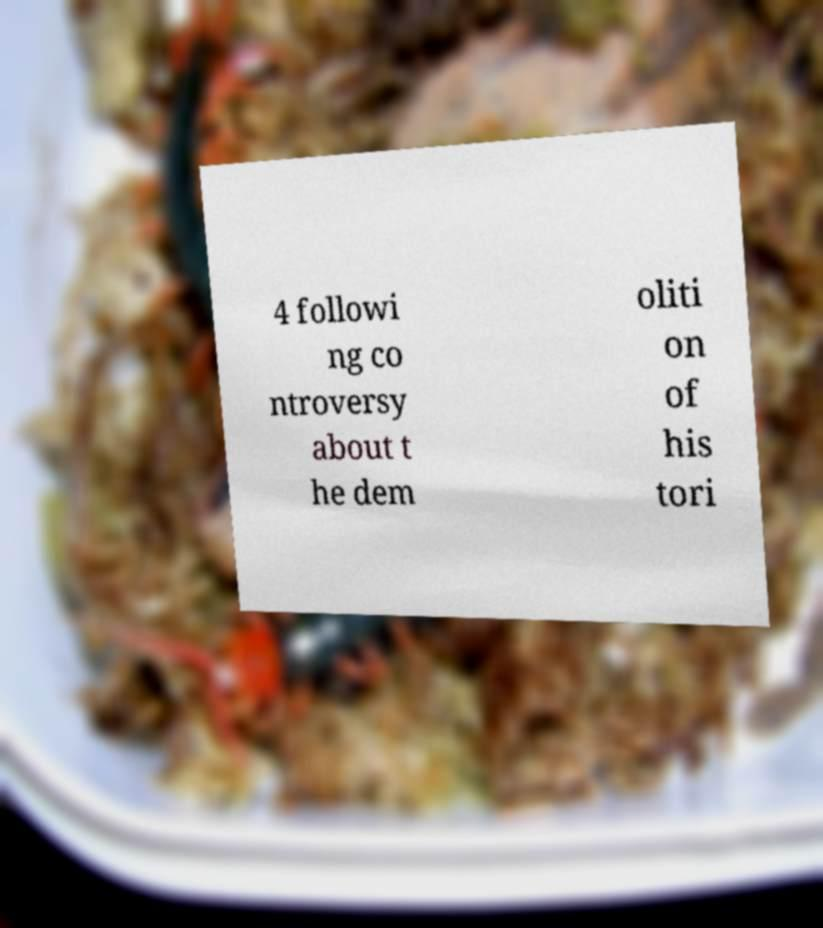I need the written content from this picture converted into text. Can you do that? 4 followi ng co ntroversy about t he dem oliti on of his tori 